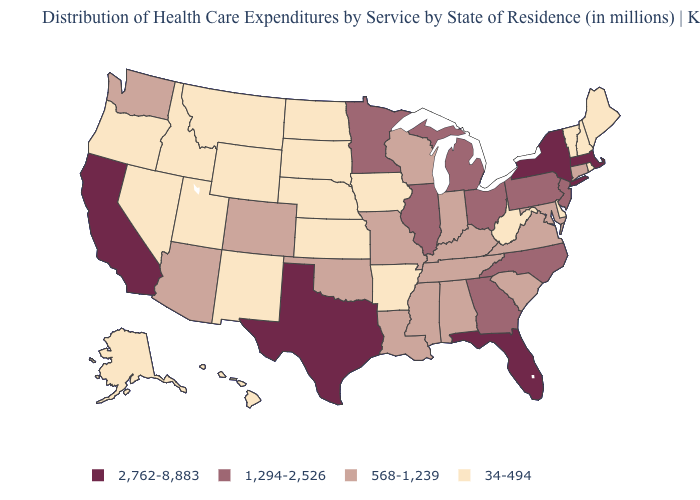Is the legend a continuous bar?
Short answer required. No. Among the states that border Indiana , which have the lowest value?
Quick response, please. Kentucky. Among the states that border Louisiana , which have the highest value?
Short answer required. Texas. What is the value of Missouri?
Short answer required. 568-1,239. What is the value of Vermont?
Keep it brief. 34-494. Among the states that border Delaware , does Maryland have the lowest value?
Concise answer only. Yes. What is the value of Ohio?
Be succinct. 1,294-2,526. Does Iowa have the highest value in the MidWest?
Quick response, please. No. Name the states that have a value in the range 2,762-8,883?
Concise answer only. California, Florida, Massachusetts, New York, Texas. Name the states that have a value in the range 2,762-8,883?
Be succinct. California, Florida, Massachusetts, New York, Texas. What is the lowest value in states that border Massachusetts?
Write a very short answer. 34-494. What is the value of Utah?
Be succinct. 34-494. Which states have the lowest value in the USA?
Give a very brief answer. Alaska, Arkansas, Delaware, Hawaii, Idaho, Iowa, Kansas, Maine, Montana, Nebraska, Nevada, New Hampshire, New Mexico, North Dakota, Oregon, Rhode Island, South Dakota, Utah, Vermont, West Virginia, Wyoming. Which states have the highest value in the USA?
Keep it brief. California, Florida, Massachusetts, New York, Texas. Does Washington have the same value as Pennsylvania?
Concise answer only. No. 